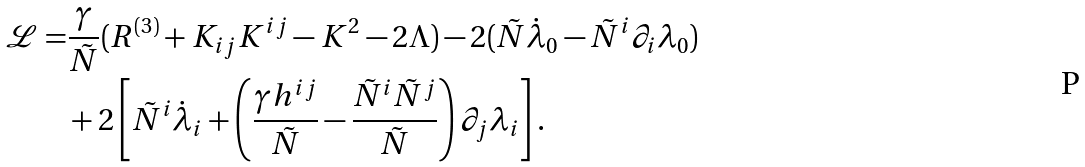<formula> <loc_0><loc_0><loc_500><loc_500>\mathcal { L } = & \frac { \gamma } { \tilde { N } } ( R ^ { ( 3 ) } + K _ { i j } K ^ { i j } - K ^ { 2 } - 2 \Lambda ) - 2 ( \tilde { N } \dot { \lambda } _ { 0 } - \tilde { N } ^ { i } \partial _ { i } \lambda _ { 0 } ) \\ & + 2 \left [ \tilde { N } ^ { i } \dot { \lambda } _ { i } + \left ( \frac { \gamma h ^ { i j } } { \tilde { N } } - \frac { \tilde { N } ^ { i } \tilde { N } ^ { j } } { \tilde { N } } \right ) \partial _ { j } \lambda _ { i } \right ] .</formula> 